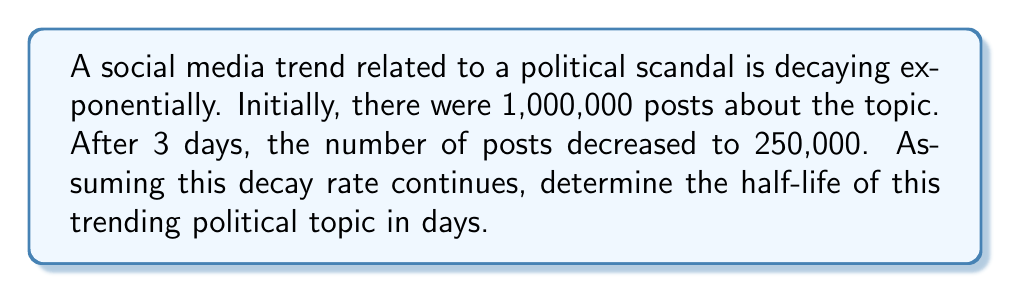What is the answer to this math problem? Let's approach this step-by-step using the exponential decay formula:

1) The exponential decay formula is:
   $$N(t) = N_0 \cdot e^{-\lambda t}$$
   where $N(t)$ is the quantity at time $t$, $N_0$ is the initial quantity, $\lambda$ is the decay constant, and $t$ is time.

2) We know:
   $N_0 = 1,000,000$
   $N(3) = 250,000$
   $t = 3$ days

3) Plugging these into the formula:
   $$250,000 = 1,000,000 \cdot e^{-3\lambda}$$

4) Simplify:
   $$\frac{1}{4} = e^{-3\lambda}$$

5) Take natural log of both sides:
   $$\ln(\frac{1}{4}) = -3\lambda$$

6) Solve for $\lambda$:
   $$\lambda = -\frac{\ln(\frac{1}{4})}{3} = \frac{\ln(4)}{3} \approx 0.4621$$

7) The half-life formula is:
   $$t_{1/2} = \frac{\ln(2)}{\lambda}$$

8) Plugging in our $\lambda$:
   $$t_{1/2} = \frac{\ln(2)}{\frac{\ln(4)}{3}} = \frac{3\ln(2)}{\ln(4)} = \frac{3\ln(2)}{2\ln(2)} = \frac{3}{2} = 1.5$$

Therefore, the half-life of the trending political topic is 1.5 days.
Answer: 1.5 days 